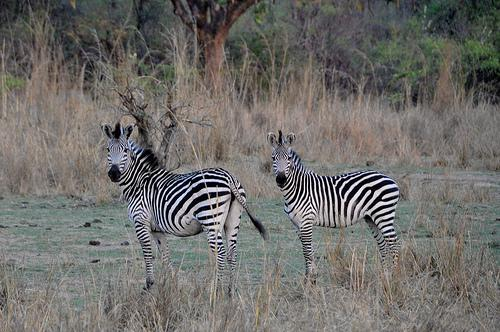Question: where are the zebras?
Choices:
A. By the pond.
B. In a field.
C. By the tree.
D. By the elephant.
Answer with the letter. Answer: B Question: how many zebras?
Choices:
A. Two.
B. One.
C. Three.
D. Four.
Answer with the letter. Answer: A Question: how many legs?
Choices:
A. Seven.
B. Six.
C. Nine.
D. Eight.
Answer with the letter. Answer: D Question: what are the zebras doing?
Choices:
A. Grazing.
B. Sleeping.
C. Standing and staring.
D. Running.
Answer with the letter. Answer: C Question: what is in the background?
Choices:
A. Lake.
B. Grass.
C. Trees.
D. Pond.
Answer with the letter. Answer: C 